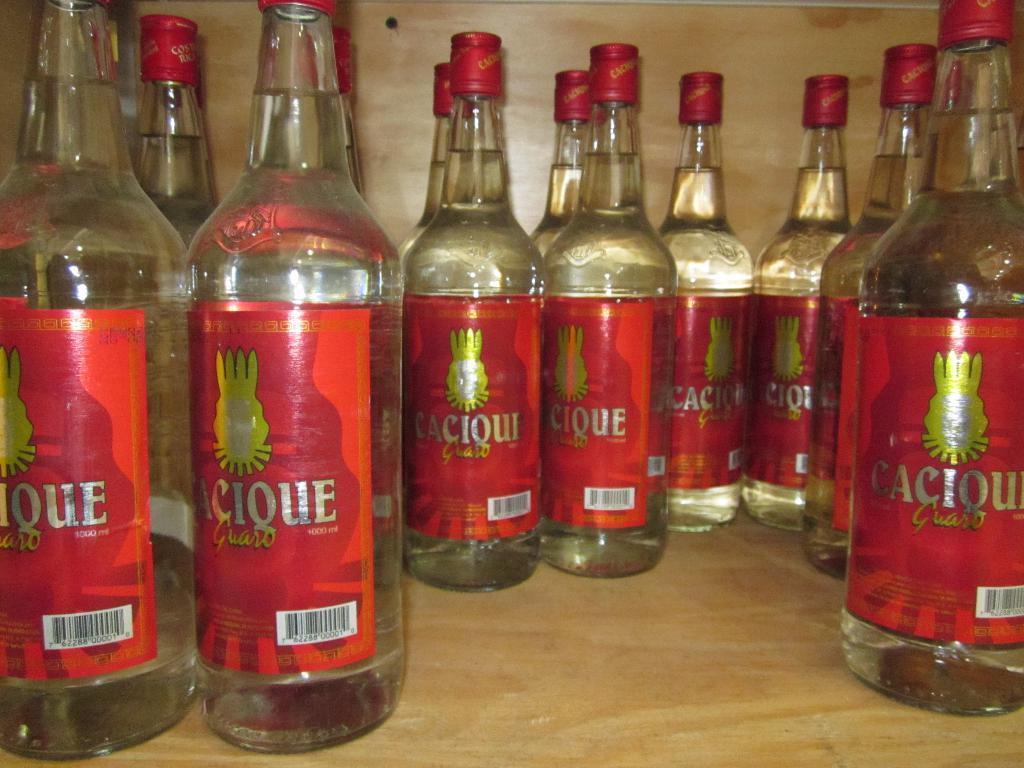In one or two sentences, can you explain what this image depicts? In this picture we can see a number a bottles placed on a table and they have a tight seal on them. 